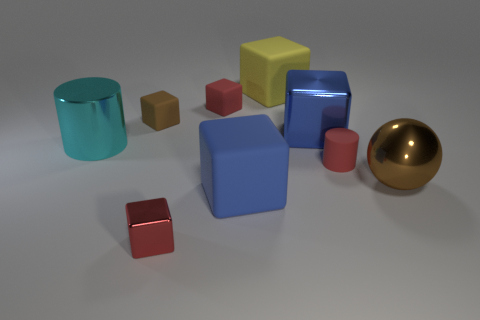What is the size of the rubber thing that is the same color as the rubber cylinder?
Your answer should be compact. Small. What number of large rubber cubes are the same color as the big metallic cube?
Make the answer very short. 1. How many things are large blocks in front of the red matte cylinder or red metallic objects?
Ensure brevity in your answer.  2. Do the brown thing that is left of the blue metal block and the metallic cube that is in front of the big metal ball have the same size?
Your answer should be compact. Yes. What number of things are either things in front of the cyan metallic cylinder or small cubes that are in front of the rubber cylinder?
Your answer should be compact. 4. Is the material of the brown sphere the same as the big blue block that is behind the shiny cylinder?
Your answer should be very brief. Yes. There is a large metal object that is both right of the large metal cylinder and left of the red rubber cylinder; what shape is it?
Keep it short and to the point. Cube. How many other things are there of the same color as the ball?
Offer a very short reply. 1. The large blue matte object is what shape?
Give a very brief answer. Cube. What color is the tiny matte block that is on the left side of the tiny rubber block on the right side of the small shiny thing?
Ensure brevity in your answer.  Brown. 